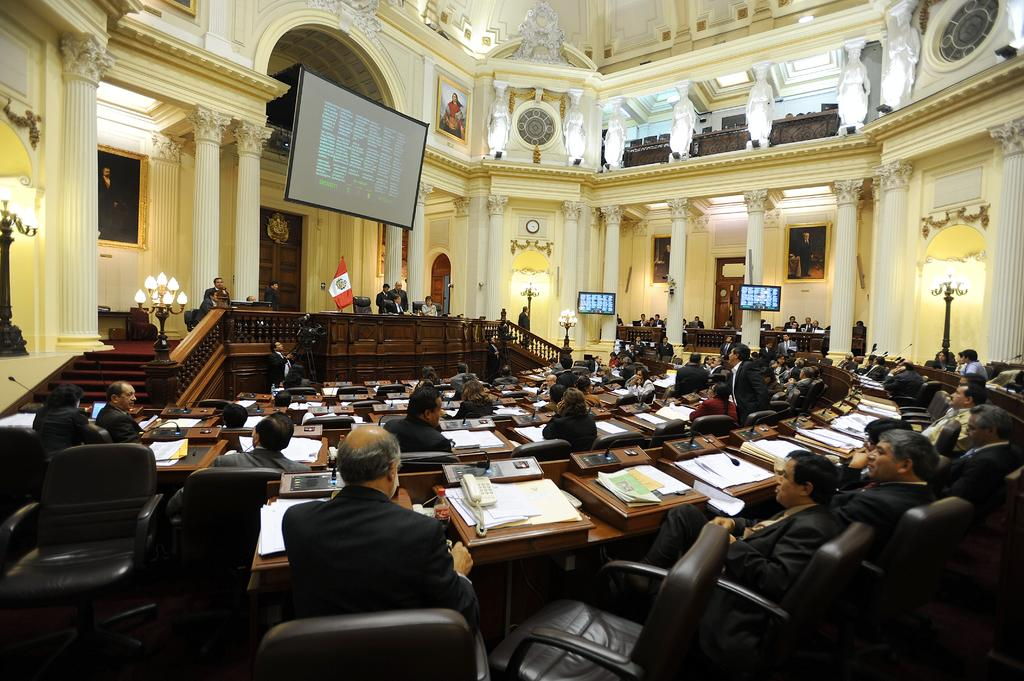What are the people in the image doing? There is a group of people sitting on chairs in the image. What objects can be seen on the table in the image? There is a telephone, papers, a bottle, and a microphone on the table in the image. What can be seen in the background of the image? There is a flag and a screen in the background of the image. What type of nation is depicted in the fictional story being told by the beast in the image? There is no nation, fictional story, or beast present in the image. 